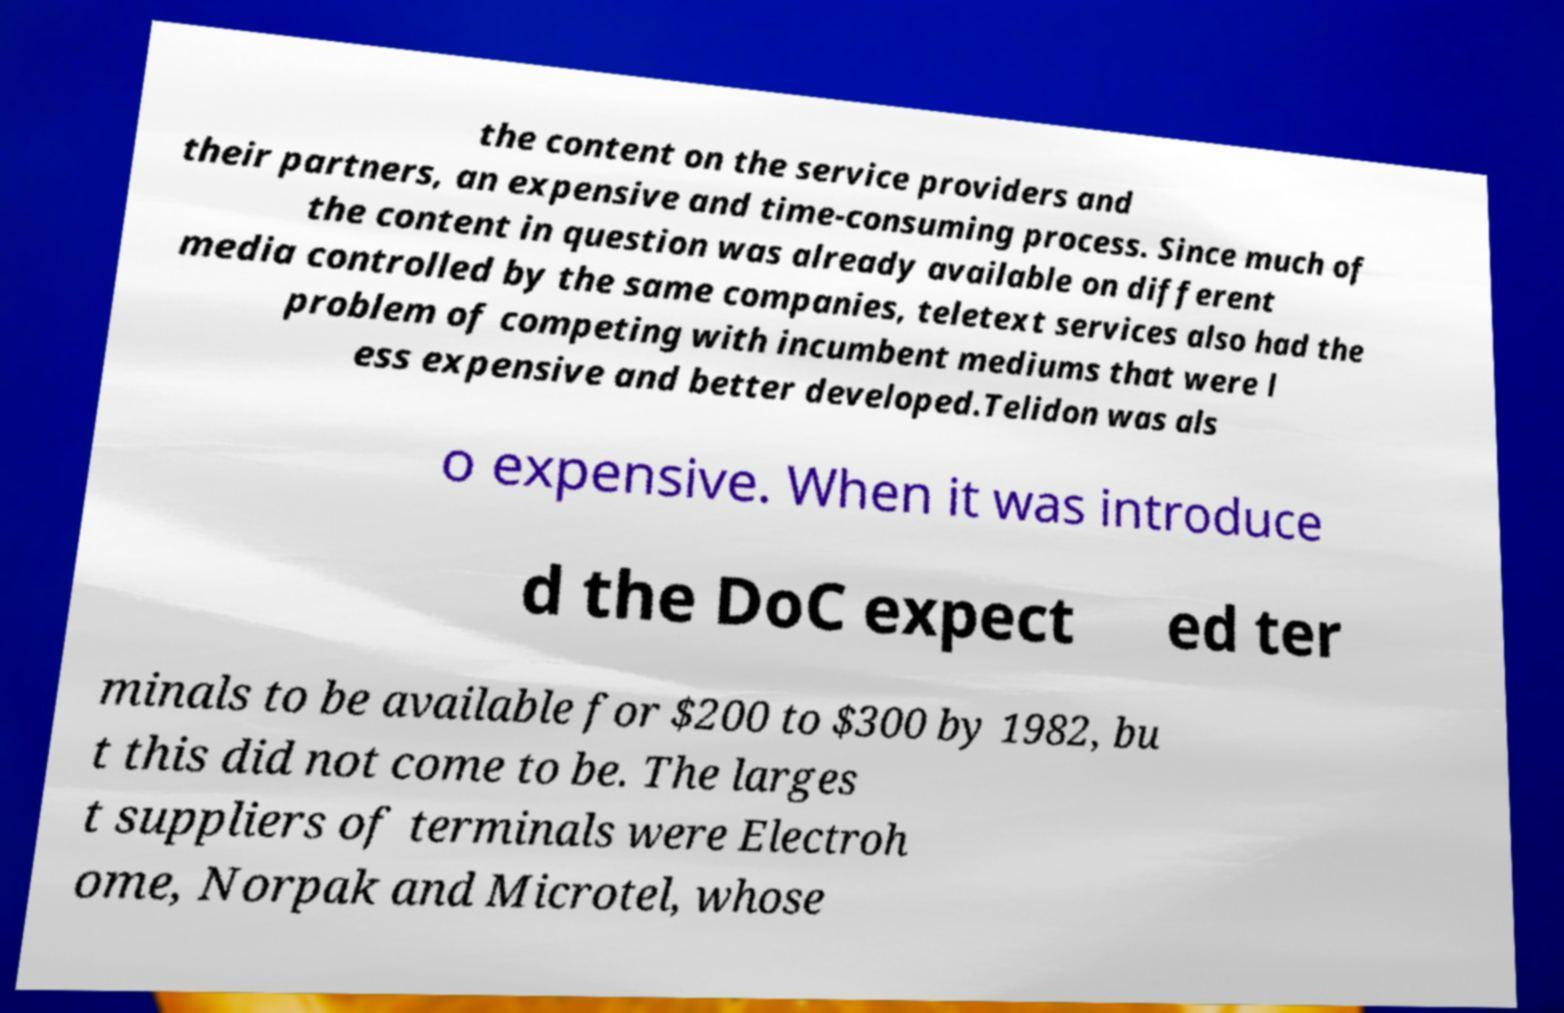Please read and relay the text visible in this image. What does it say? the content on the service providers and their partners, an expensive and time-consuming process. Since much of the content in question was already available on different media controlled by the same companies, teletext services also had the problem of competing with incumbent mediums that were l ess expensive and better developed.Telidon was als o expensive. When it was introduce d the DoC expect ed ter minals to be available for $200 to $300 by 1982, bu t this did not come to be. The larges t suppliers of terminals were Electroh ome, Norpak and Microtel, whose 